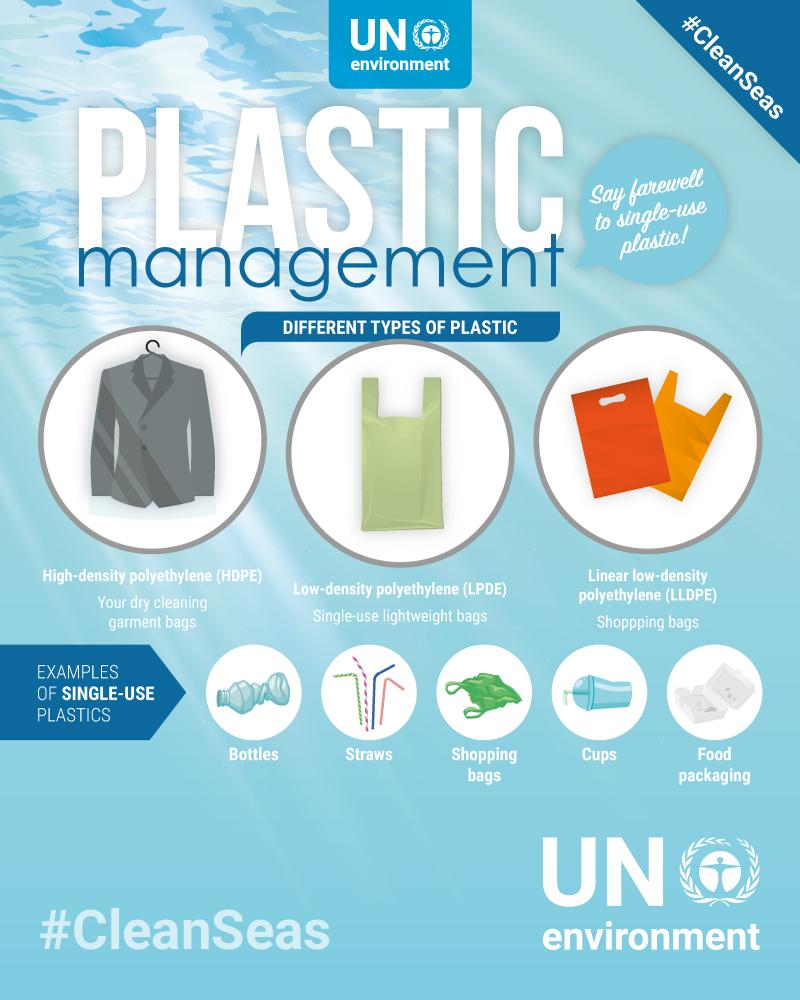Highlight a few significant elements in this photo. The use of plastic in food packaging primarily consists of single-use plastic, which is a concerning issue that requires immediate attention and action. It has been provided with an example of HDPE, specifically in the form of dry cleaning garment bags, to demonstrate the versatility and durability of the material. The colour of the single-use lightweight bags is green, not yellow. 